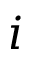<formula> <loc_0><loc_0><loc_500><loc_500>i</formula> 